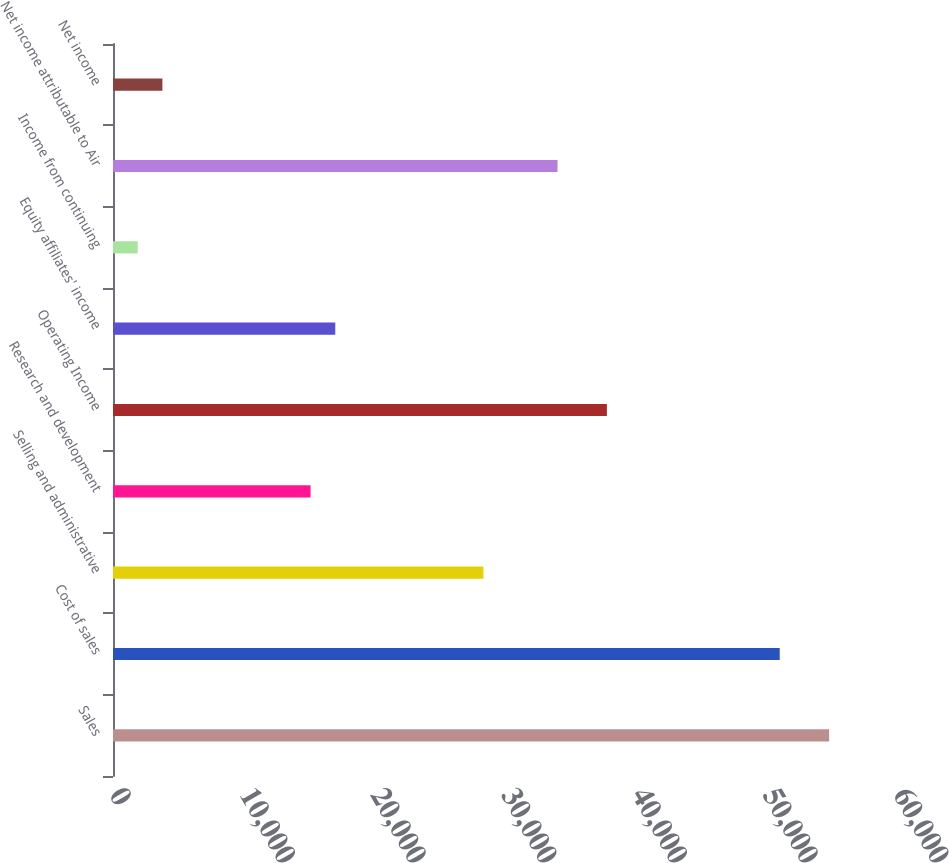Convert chart. <chart><loc_0><loc_0><loc_500><loc_500><bar_chart><fcel>Sales<fcel>Cost of sales<fcel>Selling and administrative<fcel>Research and development<fcel>Operating Income<fcel>Equity affiliates' income<fcel>Income from continuing<fcel>Net income attributable to Air<fcel>Net income<nl><fcel>54805.8<fcel>51026.3<fcel>28348.9<fcel>15120.5<fcel>37797.8<fcel>17010.2<fcel>1892.01<fcel>34018.3<fcel>3781.79<nl></chart> 